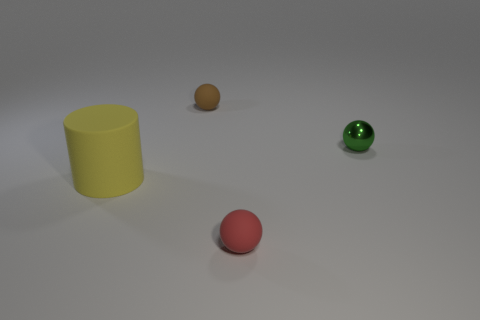There is a small thing right of the tiny sphere that is in front of the yellow thing; what is it made of?
Provide a short and direct response. Metal. There is a ball that is behind the green shiny ball; is its size the same as the green ball?
Provide a short and direct response. Yes. How many objects are either balls behind the big object or small rubber spheres that are behind the cylinder?
Keep it short and to the point. 2. Does the cylinder have the same color as the small metal sphere?
Make the answer very short. No. Are there fewer red balls right of the red object than green shiny things that are right of the yellow thing?
Offer a terse response. Yes. Are the cylinder and the tiny red thing made of the same material?
Keep it short and to the point. Yes. There is a matte object that is to the right of the large rubber object and in front of the brown ball; how big is it?
Your answer should be compact. Small. What shape is the green shiny object that is the same size as the red matte ball?
Provide a succinct answer. Sphere. What material is the small sphere that is left of the tiny ball that is in front of the tiny object that is right of the tiny red ball?
Ensure brevity in your answer.  Rubber. There is a small matte object behind the small metal thing; is its shape the same as the matte thing that is right of the tiny brown sphere?
Your response must be concise. Yes. 